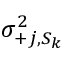<formula> <loc_0><loc_0><loc_500><loc_500>\sigma _ { + j , S _ { k } } ^ { 2 }</formula> 